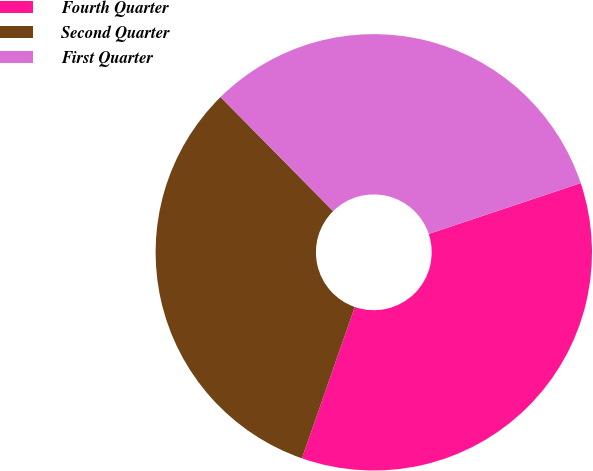Convert chart to OTSL. <chart><loc_0><loc_0><loc_500><loc_500><pie_chart><fcel>Fourth Quarter<fcel>Second Quarter<fcel>First Quarter<nl><fcel>35.48%<fcel>32.26%<fcel>32.26%<nl></chart> 